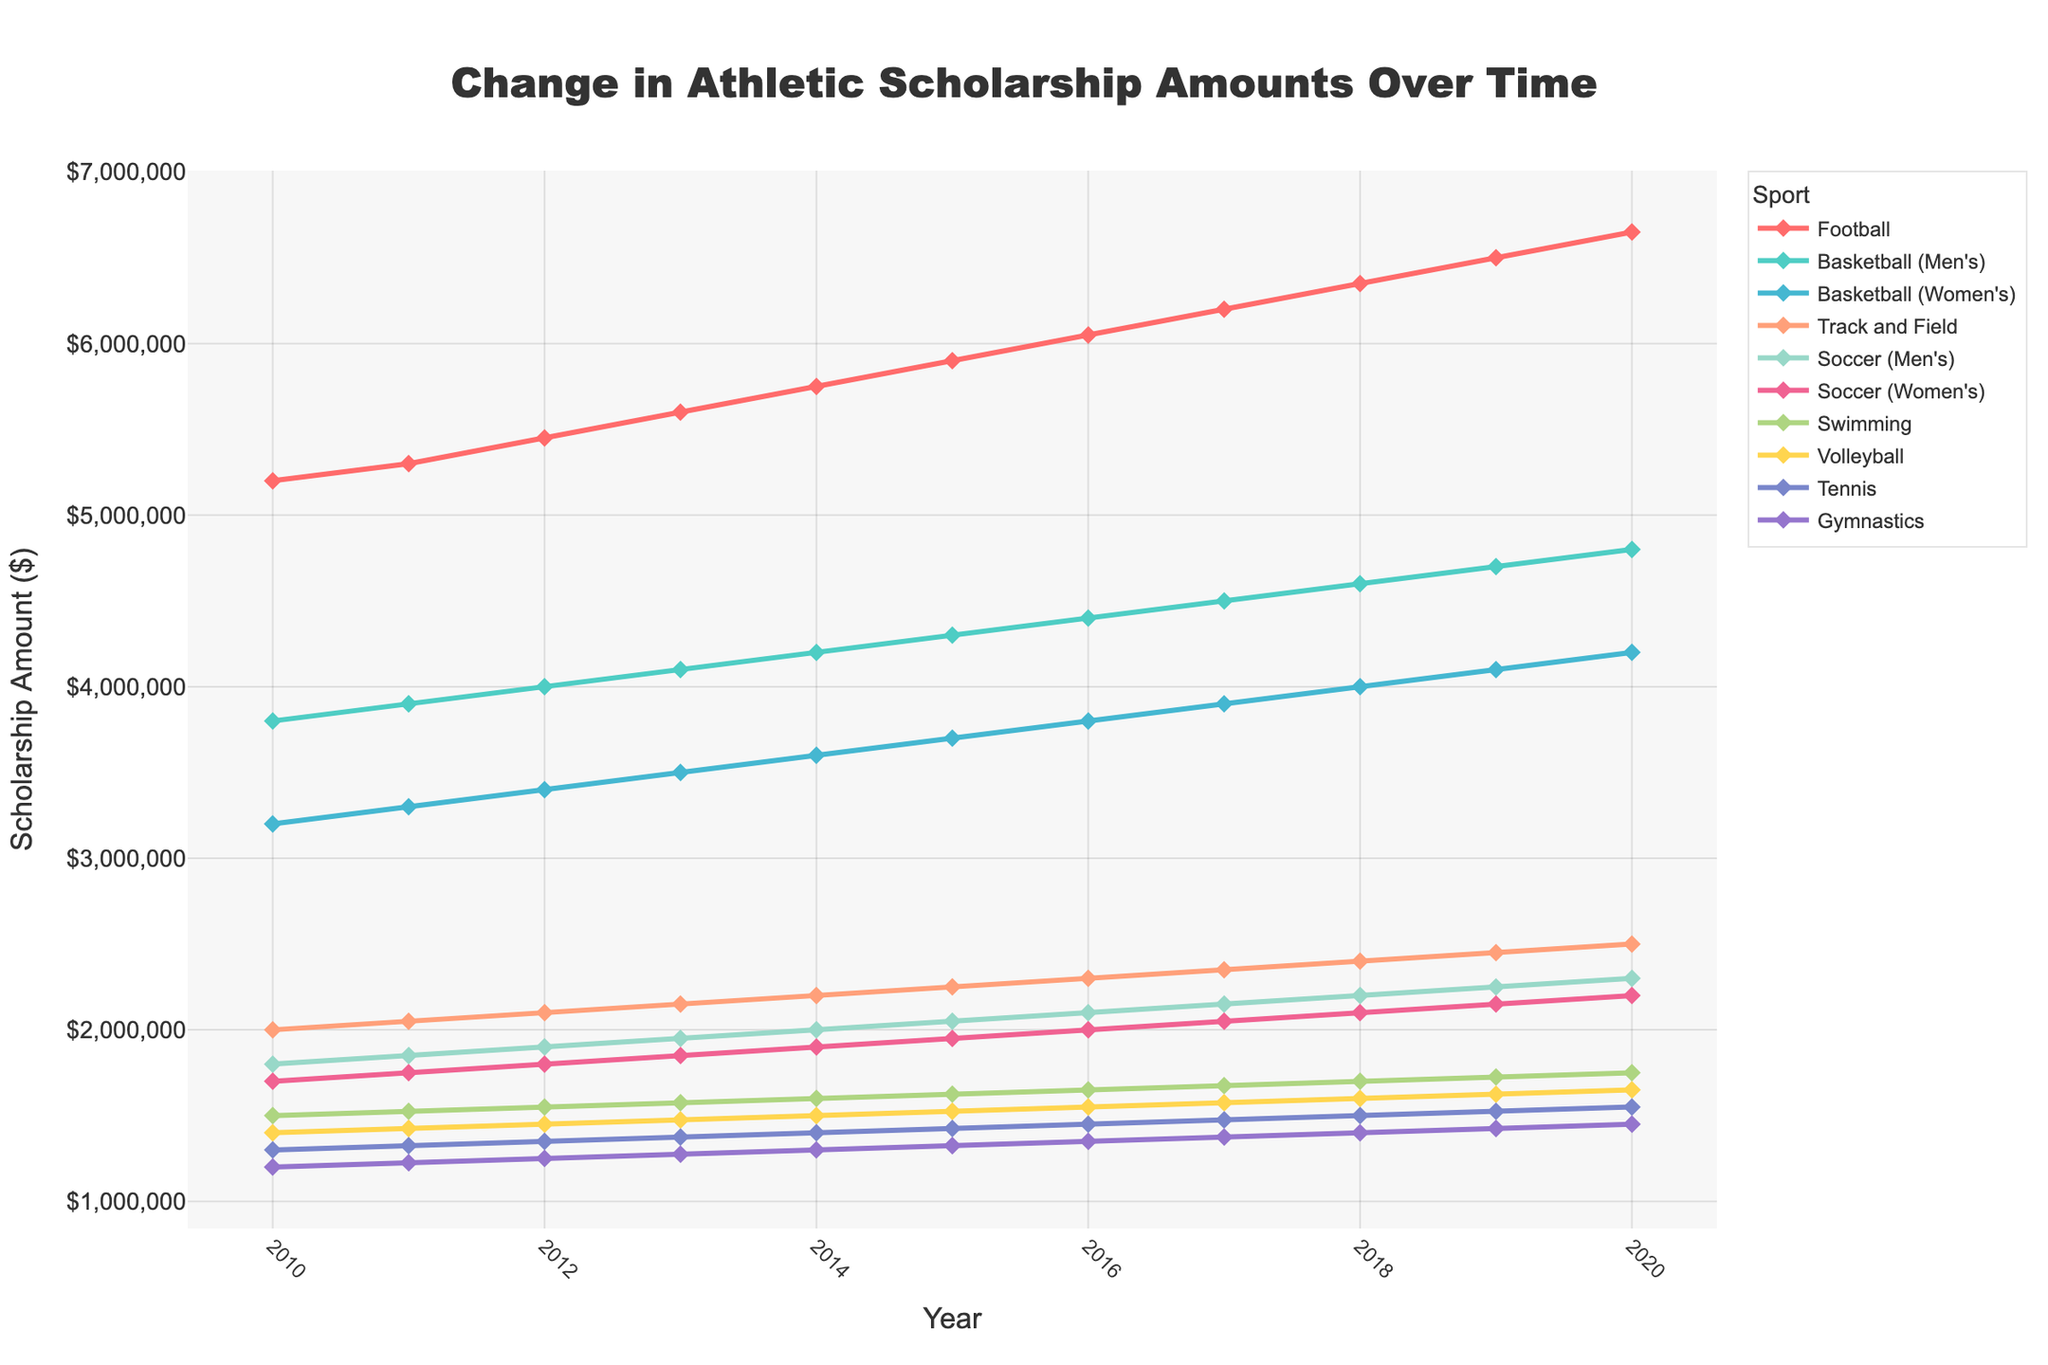What is the overall trend in the scholarship amounts for Football from 2010 to 2020? Observe the line representing Football from 2010 to 2020. The line increases steadily each year, indicating a continuous rise in the scholarship amounts.
Answer: Continuous increase Which sport had the smallest scholarship amount in 2020? Identify the end points of all lines at the year 2020 and compare their heights. The line for Gymnastics is the lowest in 2020.
Answer: Gymnastics How much did the scholarship amount for Men's Basketball increase between 2015 and 2020? Locate the Men's Basketball line in 2015 and 2020, then subtract the 2015 value from the 2020 value. The difference is 4800000 - 4300000 = 500000.
Answer: 500000 Which two sports had a similar scholarship amount in 2014? Examine the points for all sports at the year 2014 and compare their heights. Women's Basketball and Track and Field are close in 2014.
Answer: Women's Basketball and Track and Field Between which years did Volleyball see the largest increase in scholarship amounts? Trace the Volleyball line and observe the differences in consecutive years. The largest increase is from 2018 to 2019.
Answer: 2018 to 2019 Which sport had the sharpest rise in scholarship amounts from 2010 to 2020? Compare the slopes of all lines from 2010 to 2020. Football shows the sharpest rise.
Answer: Football By how much did the scholarship amount for Swimming increase from 2010 to 2013? Look at the Swimming data points for 2010 and 2013, subtract the 2010 value from the 2013 value. The difference is 1575000 - 1500000 = 75000.
Answer: 75000 How does the rate of increase for Women's Soccer compare with Men's Soccer over the period 2010 to 2020? Observe and compare the slopes of the lines for Women's and Men's Soccer. Both lines have similar slopes, indicating a similar rate of increase.
Answer: Similar rate What is the total scholarship amount for Tennis over the period 2010 to 2020? Sum the scholarship amounts for Tennis from 2010 to 2020: 1300000 + 1325000 + 1350000 + 1375000 + 1400000 + 1425000 + 1450000 + 1475000 + 1500000 + 1525000 + 1550000 = 14025000.
Answer: 14025000 Which sport shows the least consistent growth in scholarships over the decade? Observe the smoothness and uniformity of all lines. Athletics, such as Gymnastics, has a consistent and steady increase. In contrast, other sports with less uniform lines could represent less consistent growth.
Answer: Specific answer dependent on visual observation (may vary) 